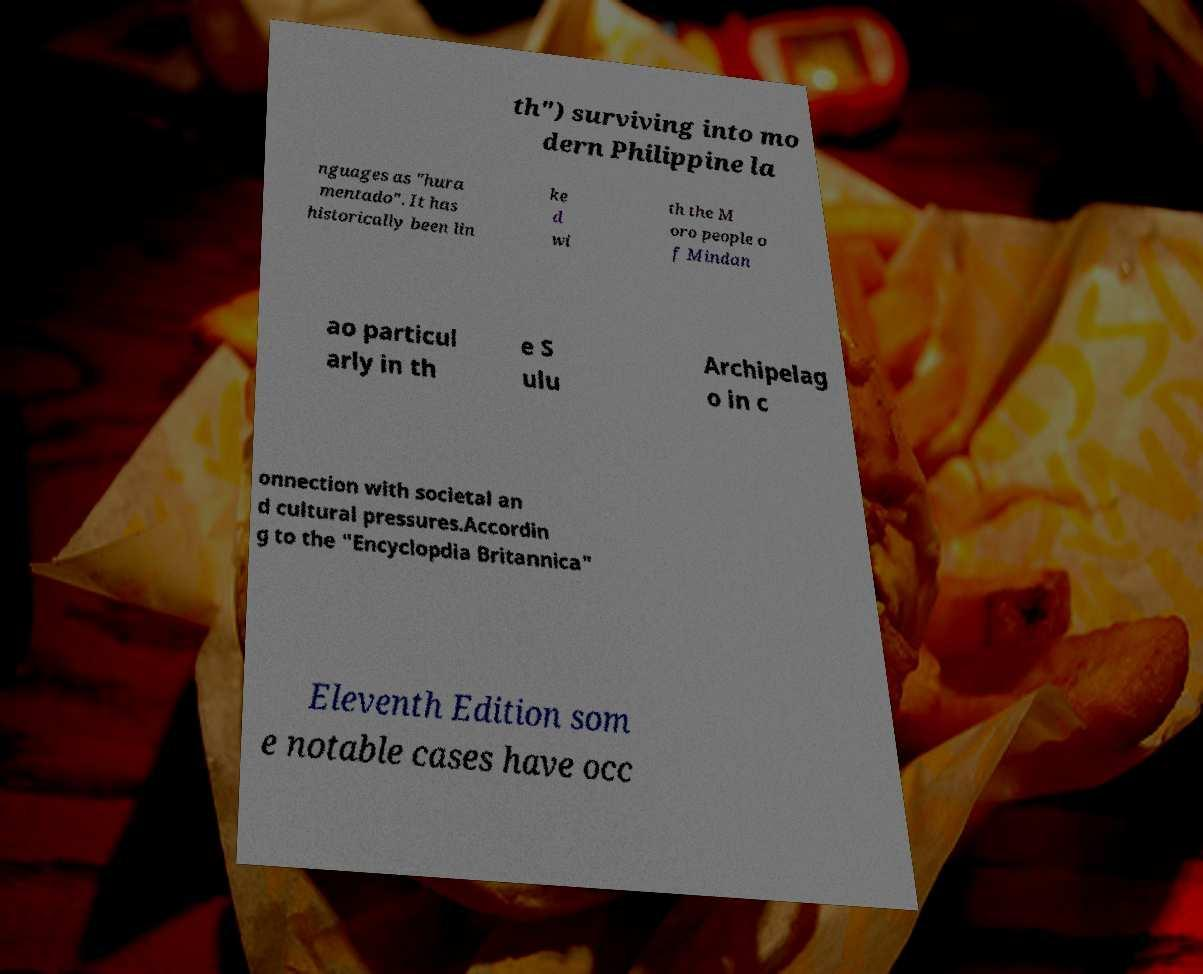Could you extract and type out the text from this image? th") surviving into mo dern Philippine la nguages as "hura mentado". It has historically been lin ke d wi th the M oro people o f Mindan ao particul arly in th e S ulu Archipelag o in c onnection with societal an d cultural pressures.Accordin g to the "Encyclopdia Britannica" Eleventh Edition som e notable cases have occ 